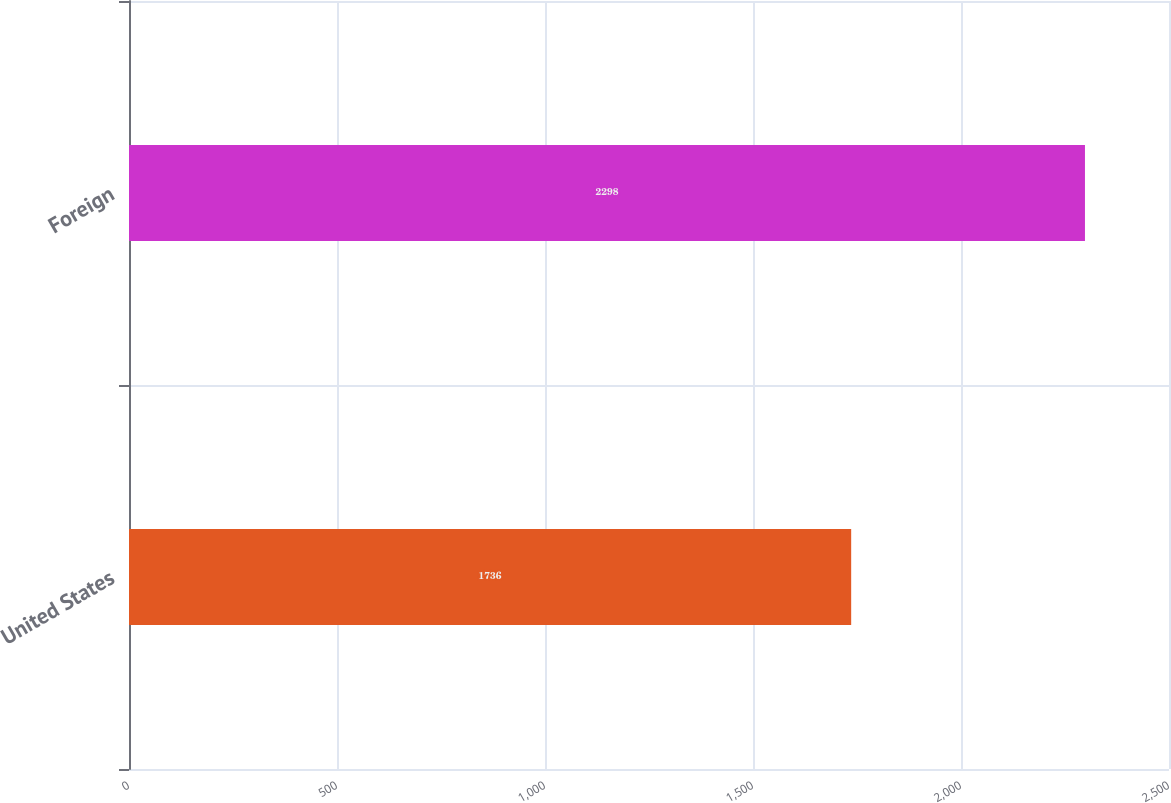Convert chart to OTSL. <chart><loc_0><loc_0><loc_500><loc_500><bar_chart><fcel>United States<fcel>Foreign<nl><fcel>1736<fcel>2298<nl></chart> 